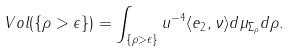<formula> <loc_0><loc_0><loc_500><loc_500>V o l ( \{ \rho > \epsilon \} ) = \int _ { \{ \rho > \epsilon \} } u ^ { - 4 } \langle e _ { 2 } , \nu \rangle d \mu _ { \Sigma _ { \rho } } d \rho .</formula> 